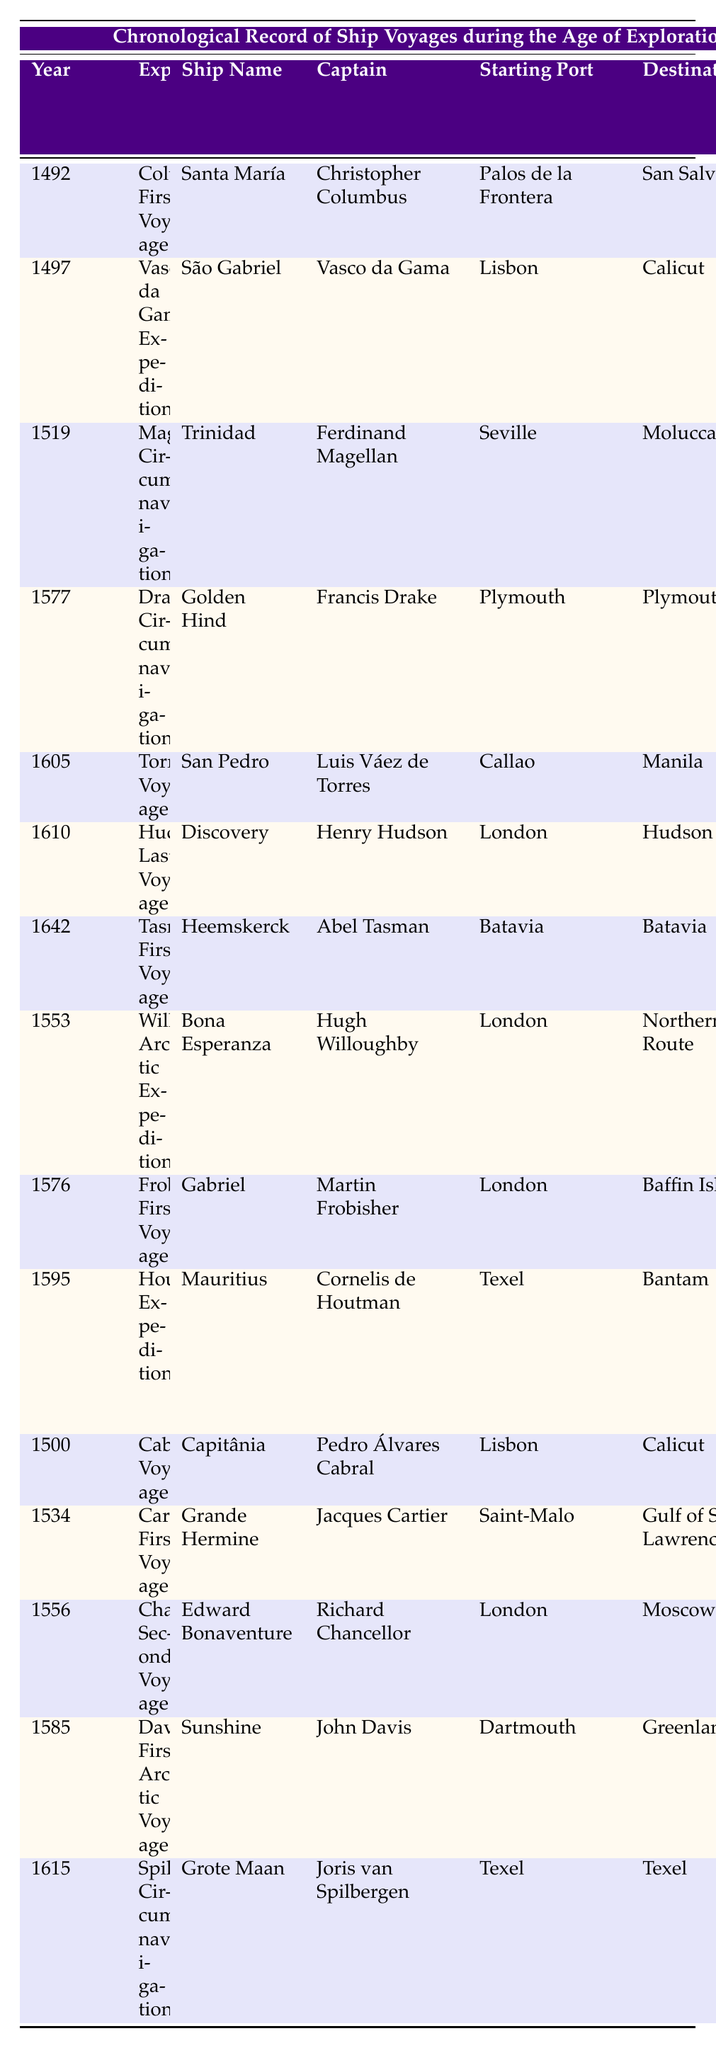What was the duration of Columbus's First Voyage? The table lists the duration for Columbus's First Voyage in the "Duration (Days)" column for the year 1492, indicating it took 70 days.
Answer: 70 days Which ship did Vasco da Gama command? By checking the "Ship Name" column for Vasco da Gama's Expedition in 1497, the ship he commanded is listed as "São Gabriel."
Answer: São Gabriel What notable discovery was made during Magellan's Circumnavigation? The "Notable Discovery" column for the expedition in 1519 specifies that the notable discovery was the "Strait of Magellan."
Answer: Strait of Magellan Who was the captain of the ship that reached Tasmania and New Zealand? The table indicates in the 1642 row that the captain of the Heemskerck, which made the voyage, was Abel Tasman.
Answer: Abel Tasman How many days did Drake's Circumnavigation take? To find this, refer to the "Duration (Days)" column for the year 1577; the duration is listed as 1020 days.
Answer: 1020 days Which expedition had the longest duration? By comparing all the values in the "Duration (Days)" column, Magellan's Circumnavigation in 1519 lasts 1081 days, making it the longest.
Answer: 1081 days Did any expedition take less than 100 days? By reviewing the "Duration (Days)" column, all durations are 70 or higher; hence, there is no expedition under 100 days.
Answer: No What was the occupation of the captain during the 1615 voyage? The table shows that Joris van Spilbergen was the captain of the Grote Maan during his Circumnavigation in 1615.
Answer: Joris van Spilbergen How many expeditions started from London? By counting the entries with "London" in the "Starting Port" column, there are four trips initiated from London.
Answer: 4 What was the average duration of voyages that started from Lisbon? The two relevant expeditions are Cabral's Voyage (186 days) and Vasco da Gama's Expedition (309 days). The sum is 495 days, and dividing by 2 gives an average of 247.5 days.
Answer: 247.5 days Which expedition was notable for the discovery of the spice trade route? Referring to the "Notable Discovery" column for Houtman's Expedition in 1595 indicates it was significant for the spice trade route to Indonesia.
Answer: Spice trade route to Indonesia How much longer did Hudson's Last Voyage take compared to Columbus's First Voyage? Hudson's Last Voyage took 407 days, while Columbus's took 70 days. The difference is 407 - 70 = 337 days.
Answer: 337 days What year did the first Arctic expedition occur? The table lists Frobisher's First Voyage under the year 1576, making it the first documented Arctic expedition.
Answer: 1576 Was there any voyage that lasted exactly one year? Reviewing the durations in the table indicates Chancellor's Second Voyage took 365 days, which fulfills the one-year condition.
Answer: Yes What destination did the ship San Pedro aim for in 1605? The table shows that the San Pedro, under Luis Váez de Torres, had its destination listed as Manila for the year 1605.
Answer: Manila 